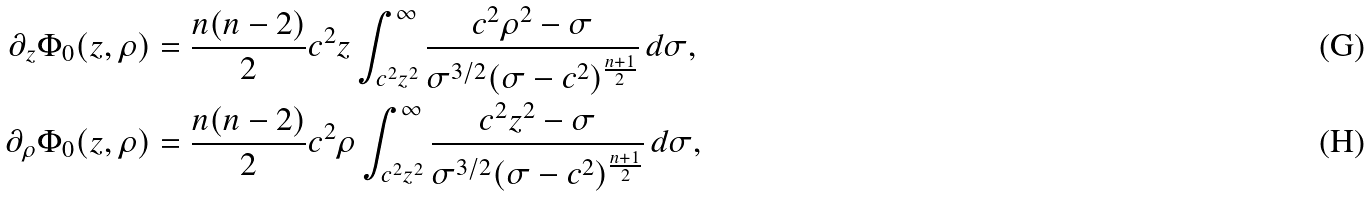<formula> <loc_0><loc_0><loc_500><loc_500>\partial _ { z } \Phi _ { 0 } ( z , \rho ) & = \frac { n ( n - 2 ) } 2 c ^ { 2 } z \int _ { c ^ { 2 } z ^ { 2 } } ^ { \infty } \frac { c ^ { 2 } \rho ^ { 2 } - \sigma } { \sigma ^ { 3 / 2 } ( \sigma - c ^ { 2 } ) ^ { \frac { n + 1 } 2 } } \, d \sigma , \\ \partial _ { \rho } \Phi _ { 0 } ( z , \rho ) & = \frac { n ( n - 2 ) } 2 c ^ { 2 } \rho \int _ { c ^ { 2 } z ^ { 2 } } ^ { \infty } \frac { c ^ { 2 } z ^ { 2 } - \sigma } { \sigma ^ { 3 / 2 } ( \sigma - c ^ { 2 } ) ^ { \frac { n + 1 } 2 } } \, d \sigma ,</formula> 